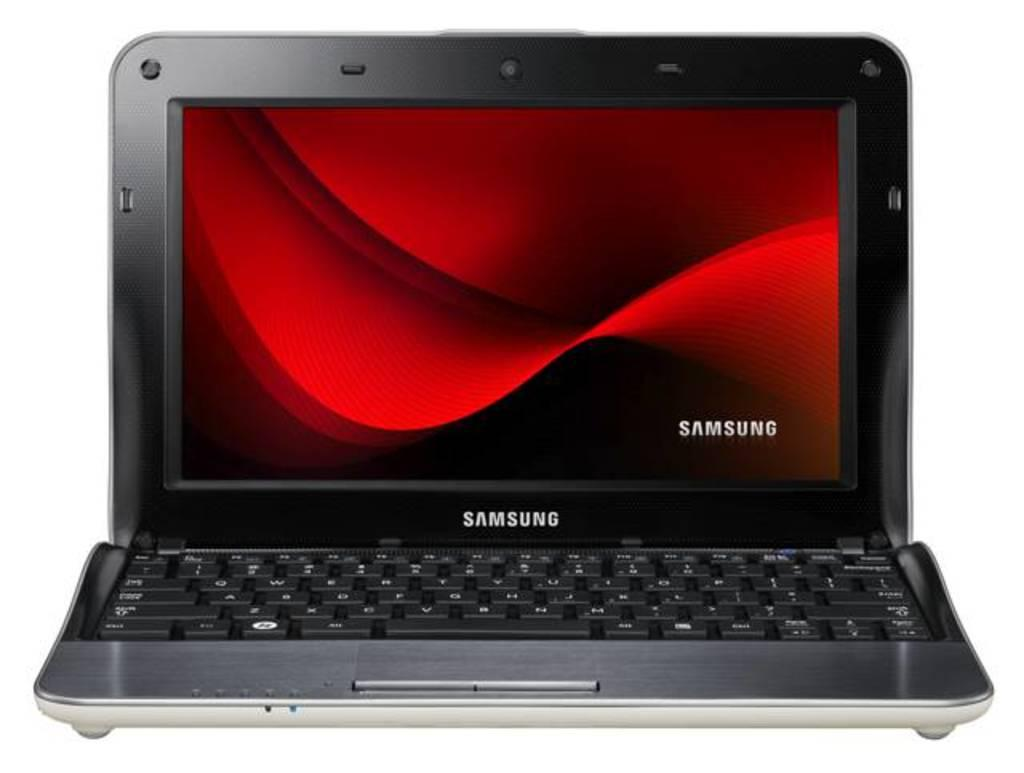<image>
Relay a brief, clear account of the picture shown. A Samsung laptop is open with a red screensaver. 